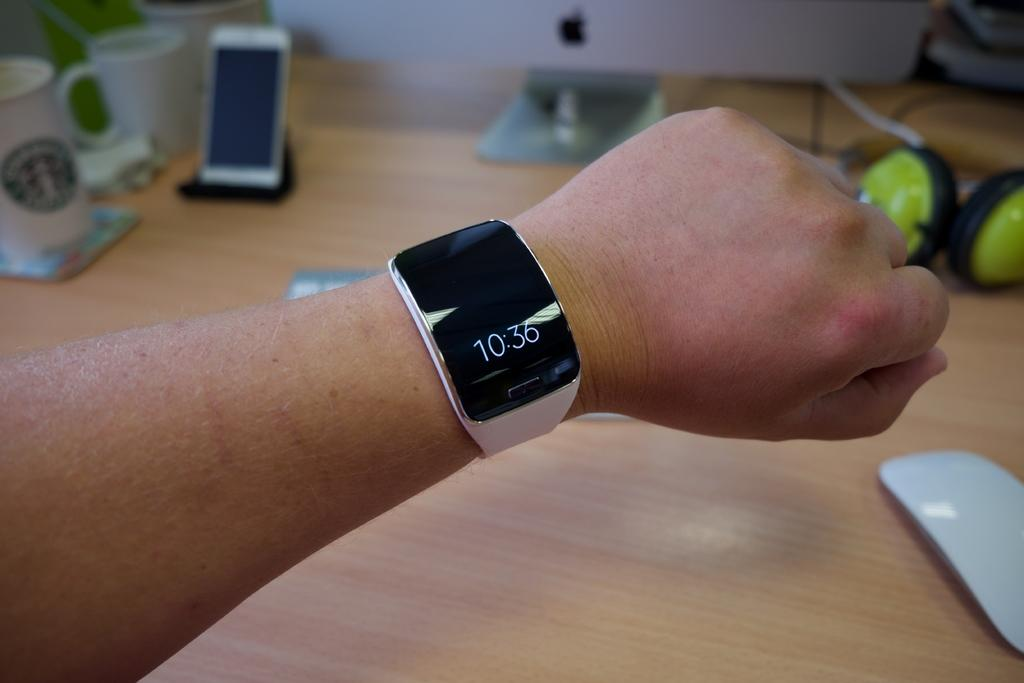<image>
Summarize the visual content of the image. a wrist watch reads 10:36 on an outstretched wrist 